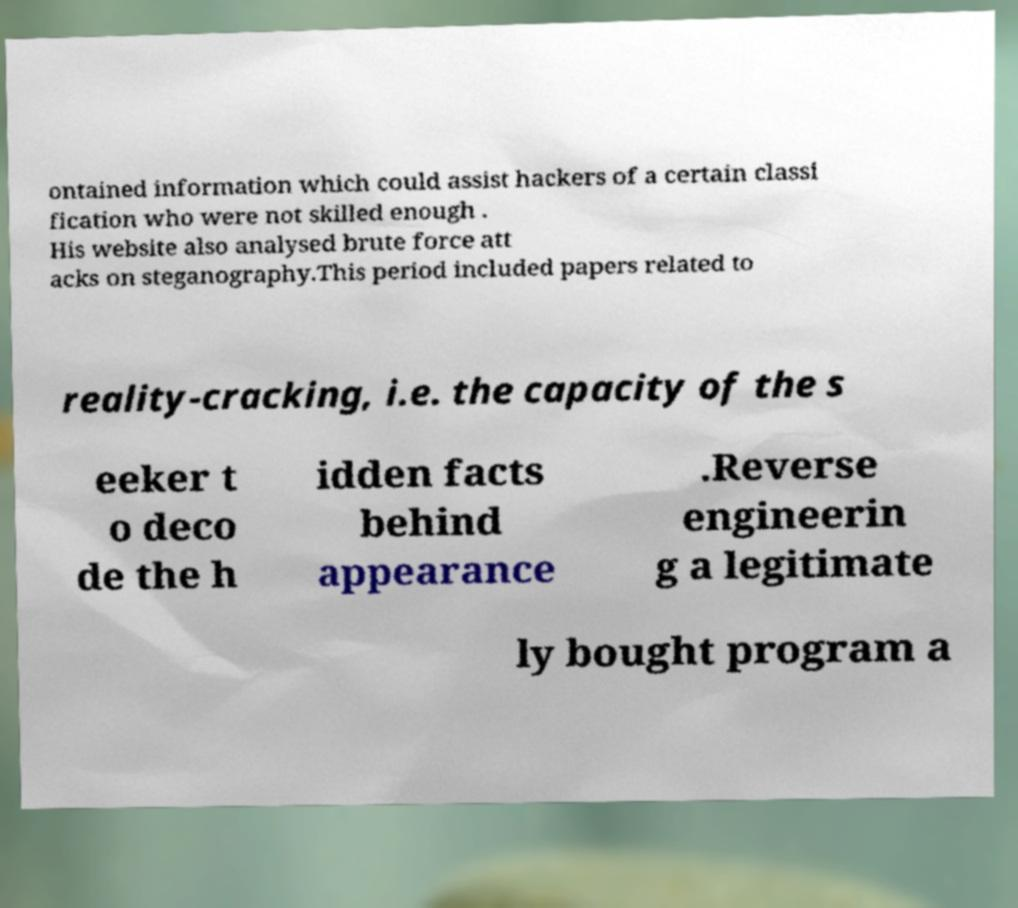Can you accurately transcribe the text from the provided image for me? ontained information which could assist hackers of a certain classi fication who were not skilled enough . His website also analysed brute force att acks on steganography.This period included papers related to reality-cracking, i.e. the capacity of the s eeker t o deco de the h idden facts behind appearance .Reverse engineerin g a legitimate ly bought program a 